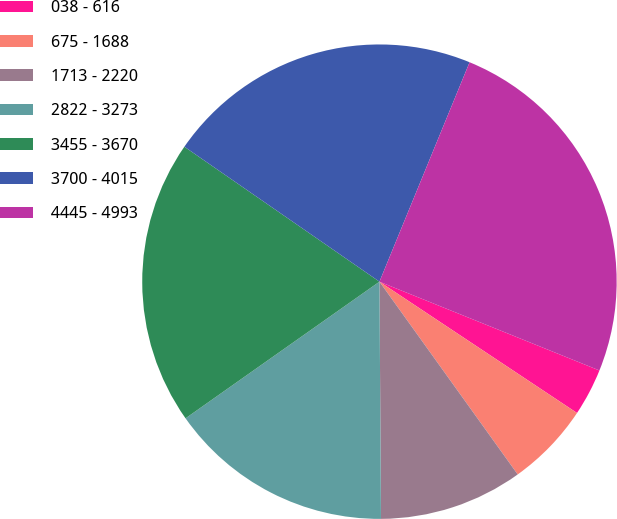Convert chart. <chart><loc_0><loc_0><loc_500><loc_500><pie_chart><fcel>038 - 616<fcel>675 - 1688<fcel>1713 - 2220<fcel>2822 - 3273<fcel>3455 - 3670<fcel>3700 - 4015<fcel>4445 - 4993<nl><fcel>3.23%<fcel>5.76%<fcel>9.8%<fcel>15.33%<fcel>19.4%<fcel>21.57%<fcel>24.9%<nl></chart> 